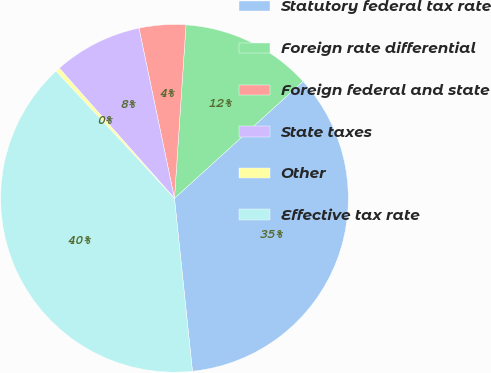Convert chart. <chart><loc_0><loc_0><loc_500><loc_500><pie_chart><fcel>Statutory federal tax rate<fcel>Foreign rate differential<fcel>Foreign federal and state<fcel>State taxes<fcel>Other<fcel>Effective tax rate<nl><fcel>35.1%<fcel>12.19%<fcel>4.33%<fcel>8.26%<fcel>0.4%<fcel>39.71%<nl></chart> 